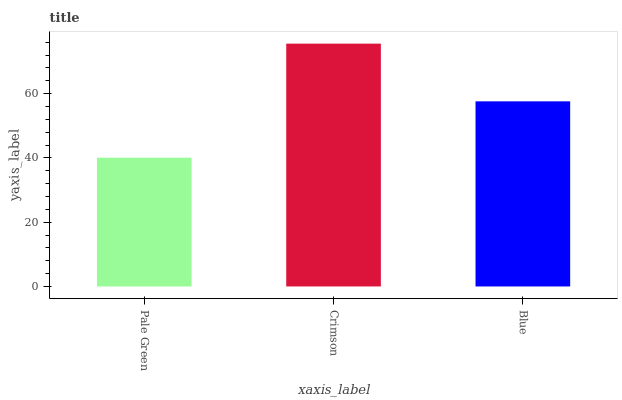Is Pale Green the minimum?
Answer yes or no. Yes. Is Crimson the maximum?
Answer yes or no. Yes. Is Blue the minimum?
Answer yes or no. No. Is Blue the maximum?
Answer yes or no. No. Is Crimson greater than Blue?
Answer yes or no. Yes. Is Blue less than Crimson?
Answer yes or no. Yes. Is Blue greater than Crimson?
Answer yes or no. No. Is Crimson less than Blue?
Answer yes or no. No. Is Blue the high median?
Answer yes or no. Yes. Is Blue the low median?
Answer yes or no. Yes. Is Pale Green the high median?
Answer yes or no. No. Is Crimson the low median?
Answer yes or no. No. 